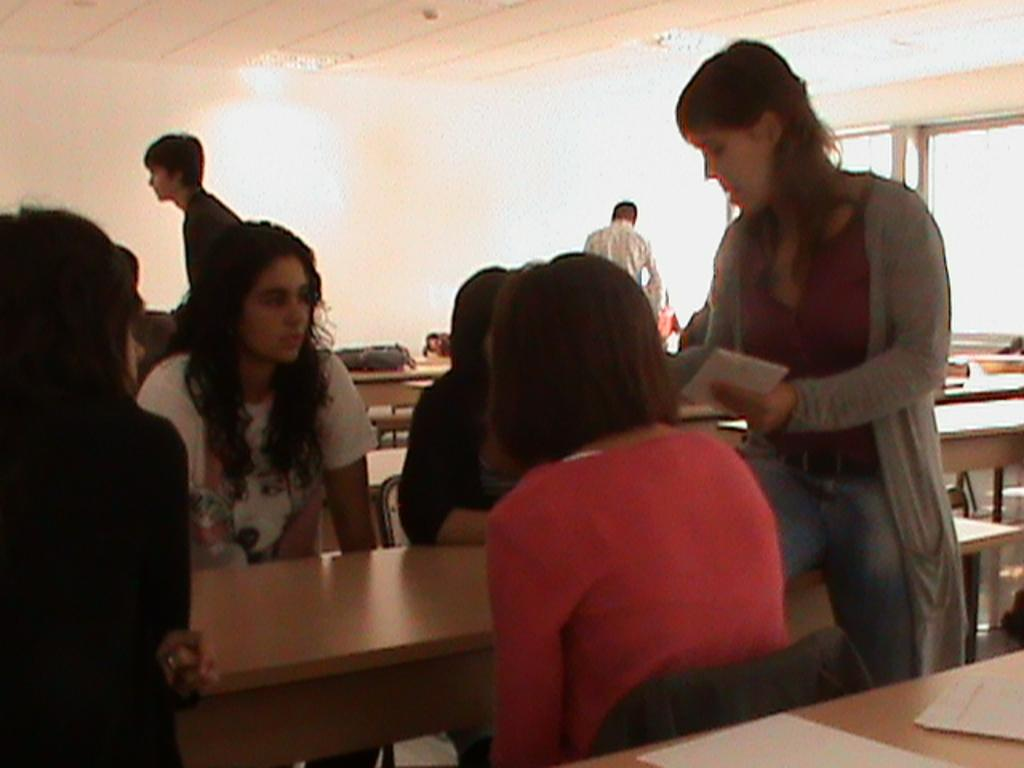How many groups of people can be seen in the image? There are two groups of people in the image, one on each side. What is the woman in the right corner of the image doing? The woman is sitting on a table in the right corner of the image. Can you describe the people visible in the background of the image? There are people visible in the background of the image, but their specific actions or positions cannot be determined from the provided facts. What type of poison is being used by the people in the image? There is no mention of poison or any toxic substances in the image. --- Facts: 1. There is a car in the image. 2. The car is parked on the street. 3. There are trees on both sides of the street. 4. The sky is visible in the image. Absurd Topics: parrot, sand, dance Conversation: What is the main subject of the image? The main subject of the image is a car. Where is the car located in the image? The car is parked on the street. What can be seen on both sides of the street in the image? There are trees on both sides of the street. What is visible in the background of the image? The sky is visible in the image. Reasoning: Let's think step by step in order to produce the conversation. We start by identifying the main subject of the image, which is the car. Then, we describe the location of the car, noting that it is parked on the street. Next, we mention the presence of trees on both sides of the street, which provides context for the setting. Finally, we acknowledge the presence of the sky in the background, which gives a sense of the weather or time of day. Absurd Question/Answer: Can you tell me how many parrots are sitting on the car in the image? There are no parrots visible in the image; it features a car parked on the street with trees on both sides and the sky visible in the background. --- Facts: 1. There is a person holding a camera in the image. 2. The person is standing on a bridge. 3. There are boats visible in the image. 4. The sky is visible in the image. Absurd Topics: lion Conversation: What is the person in the image doing? The person in the image is holding a camera. Where is the person in the image standing? The person in the image is standing on a bridge. What else can be seen in the image? There are boats visible in the image. What is visible in the background of the image? The sky is visible in the background of the image. Reasoning: Let's think step by step in order to produce the conversation. We start by identifying the main subject of the image, which is the person holding a camera. Next, we describe the specific location of the 